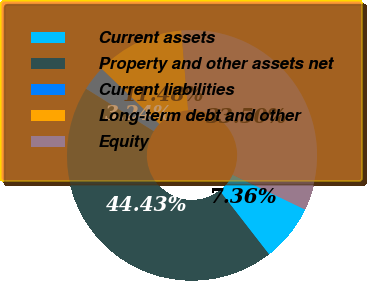Convert chart. <chart><loc_0><loc_0><loc_500><loc_500><pie_chart><fcel>Current assets<fcel>Property and other assets net<fcel>Current liabilities<fcel>Long-term debt and other<fcel>Equity<nl><fcel>7.36%<fcel>44.43%<fcel>3.24%<fcel>11.48%<fcel>33.5%<nl></chart> 